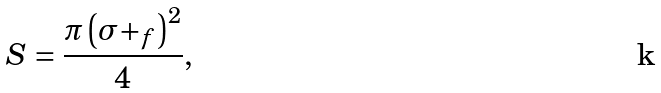Convert formula to latex. <formula><loc_0><loc_0><loc_500><loc_500>S = \frac { \pi \left ( \sigma + _ { f } \right ) ^ { 2 } } { 4 } ,</formula> 